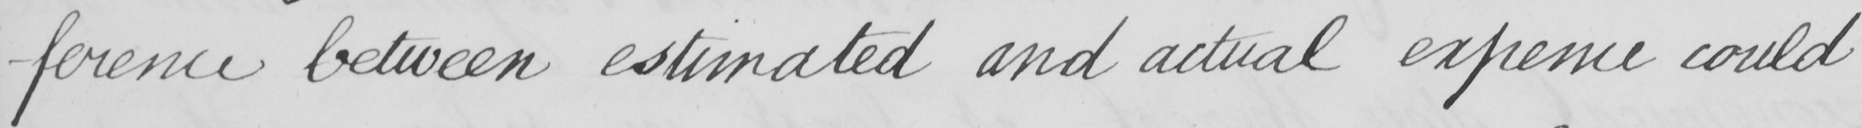Please provide the text content of this handwritten line. -ference between estimated and actual expence could 